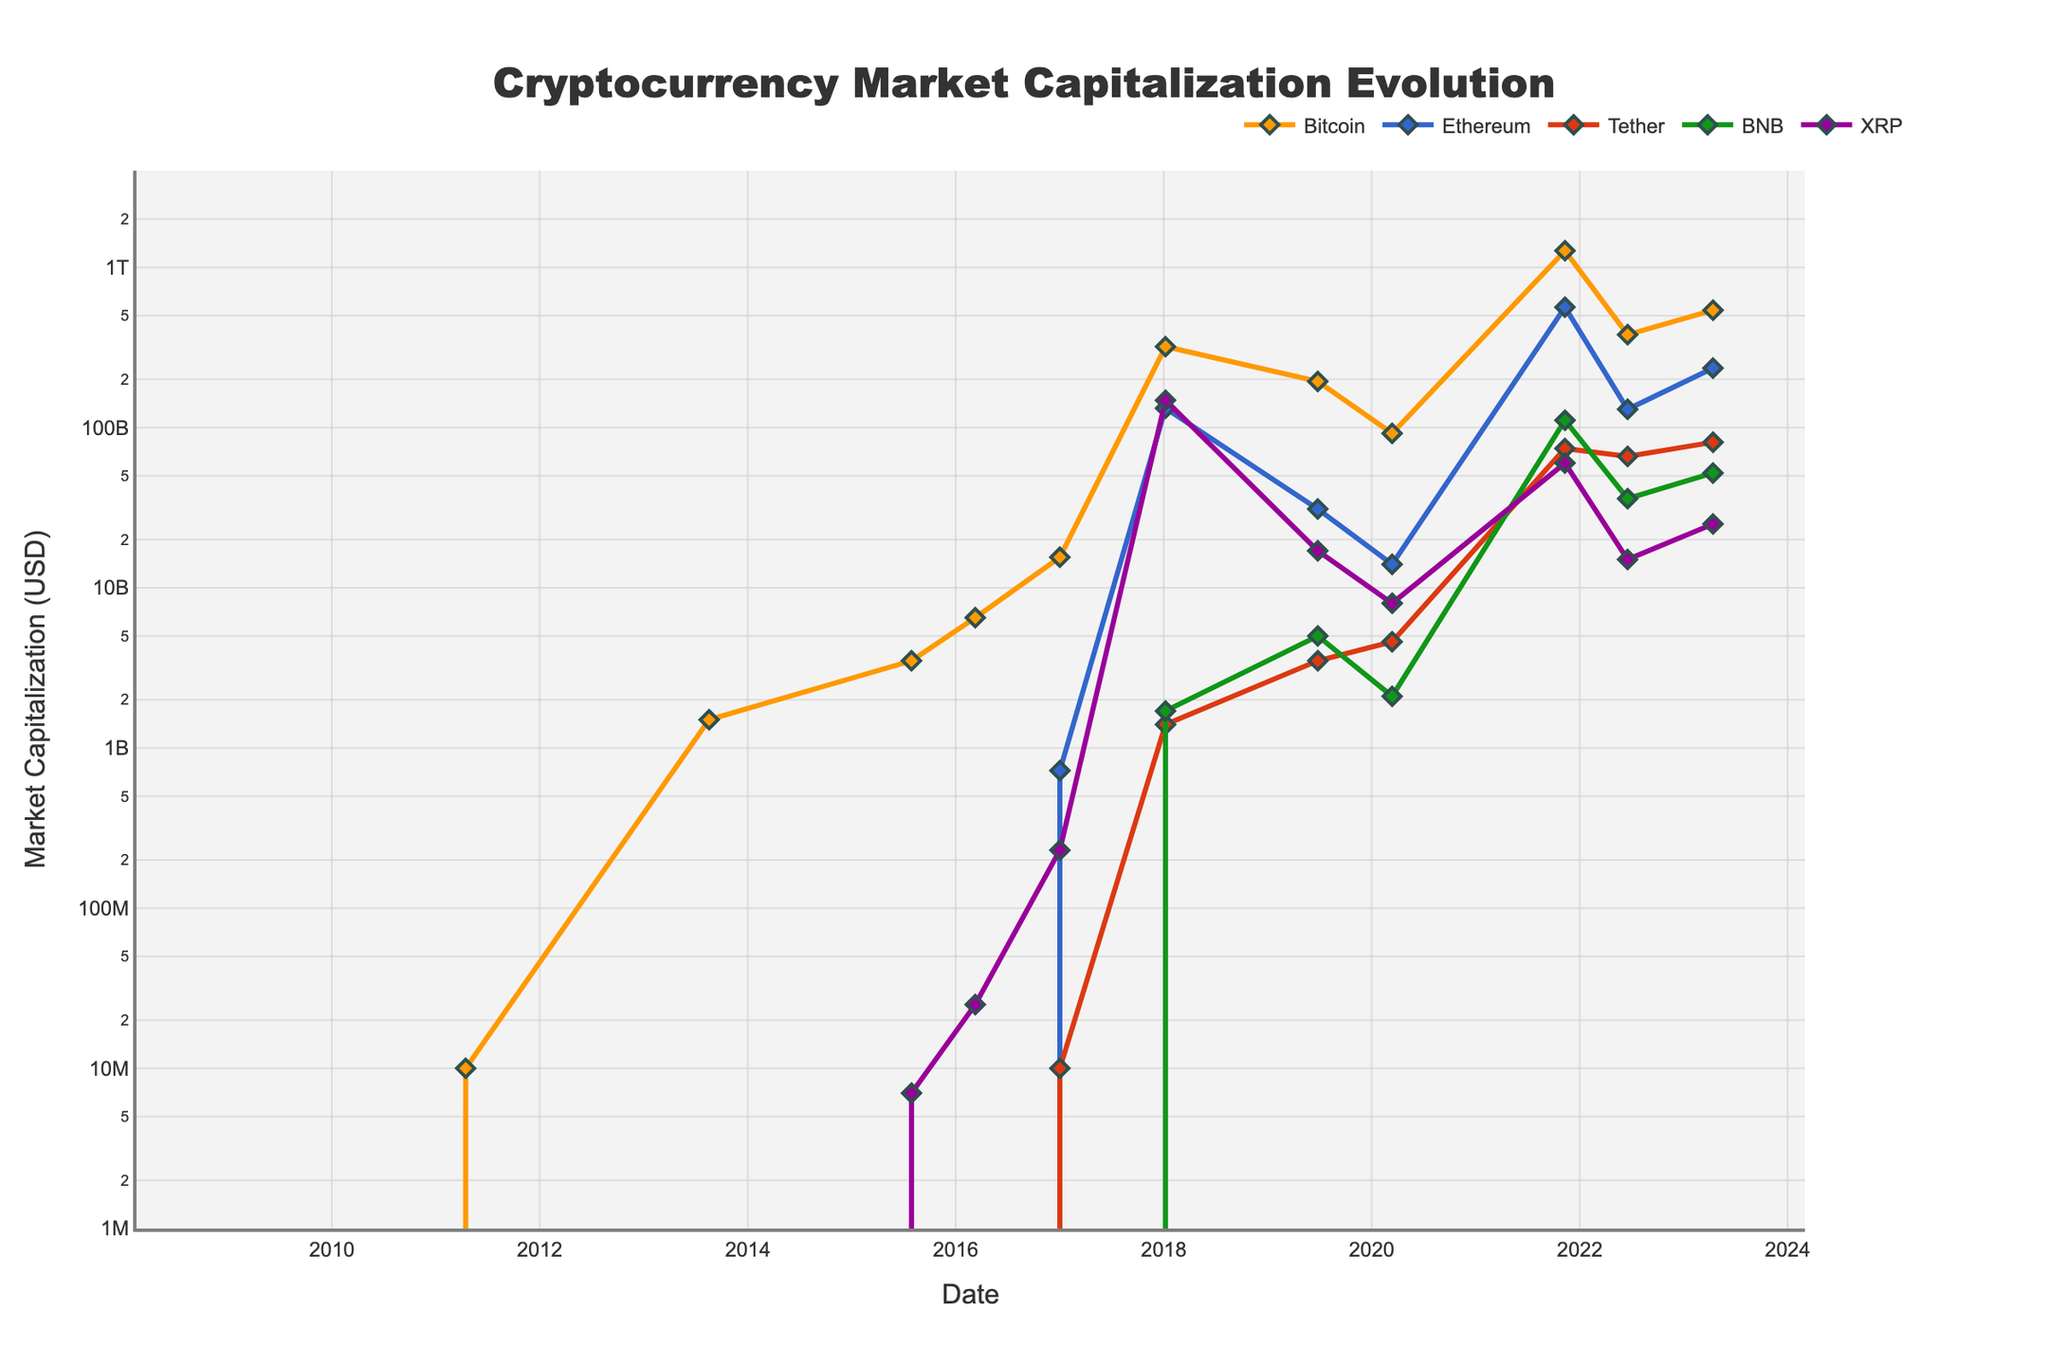Which cryptocurrency had the highest market capitalization by the end of the data period? Looking at the figure at the endpoint (2023-04-14), compare the heights of the lines. Bitcoin reaches the highest value.
Answer: Bitcoin How does the market capitalization of Ethereum in 2021 compare to that in 2020? Identify the points for Ethereum in 2020 and 2021. In 2020, it is $14 billion, and in 2021, it is $564 billion. Subtract $14 billion from $564 billion to get the difference.
Answer: $550 billion increase Which two cryptocurrencies showed significant growth from 2019 to 2021? Examine the steepest slopes between 2019 and 2021. Bitcoin and Ethereum show the most substantial increases in their lines.
Answer: Bitcoin and Ethereum What was the market capitalization of Tether in 2018, and how did it change by 2023? Locate Tether's line at 2018 and 2023. In 2018, it's $1.4 billion, and in 2023, it's $81 billion. Subtract $1.4 billion from $81 billion.
Answer: $79.6 billion increase Compare the market capitalization of Bitcoin and Ethereum in 2017. Which was higher and by how much? Identify Bitcoin and Ethereum lines in 2017. Bitcoin is $15.5 billion, and Ethereum is $0.722 billion. Subtract Ethereum's value from Bitcoin's.
Answer: Bitcoin by $14.778 billion How did the market capitalization of XRP change from 2018 to 2021? Look at XRP's values in 2018 and 2021. In 2018, it is $148 billion, and in 2021, $60 billion. Subtract 2021 from 2018 to find the decrease.
Answer: $88 billion decrease In terms of market capitalization, which cryptocurrency had the least value in 2009, and how does it compare to its value in 2023? In 2009, all values were $0. Compare these to the 2023 values. XRP has the least value growth from $0 to $25 billion.
Answer: XRP by $25 billion Between 2016 and 2018, which cryptocurrency had the most significant increase in market capitalization? Compare 2016 and 2018 values for each currency. Bitcoin increased from $6.5 billion to $320 billion, which is the highest increase.
Answer: Bitcoin What was the approximate market capitalization growth for BNB from 2019 to 2023? Identify BNB values in 2019 ($5 billion) and 2023 ($52 billion). Subtract 2019 from 2023 to find the growth.
Answer: $47 billion Examine the 2022 values; which currency showed a sharp decline from the 2021 peak? Compare 2021 and 2022 values. Bitcoin dropped from $1,270 billion to $380 billion, which is a sharp decline.
Answer: Bitcoin 